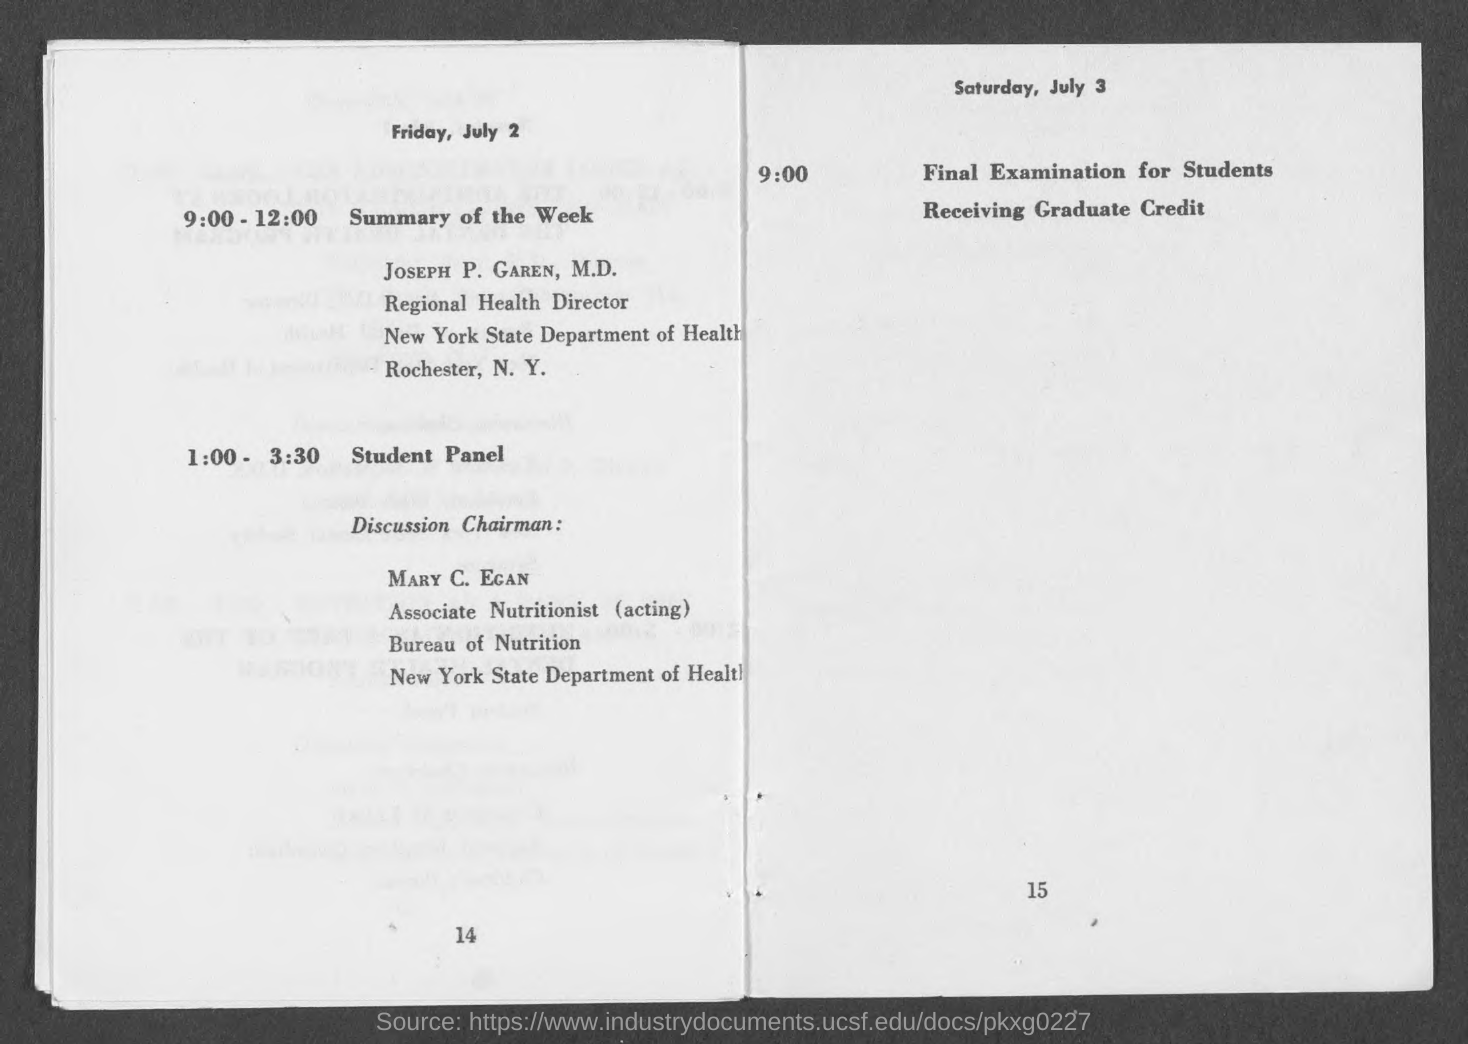Specify some key components in this picture. The speaker will present a summary of the week, and the presenter is Joseph P. Garen. The final examination for students receiving graduate credit will take place on Saturday, July 3. Mary C. Egan is the Discussion Chairman for the student panel. 